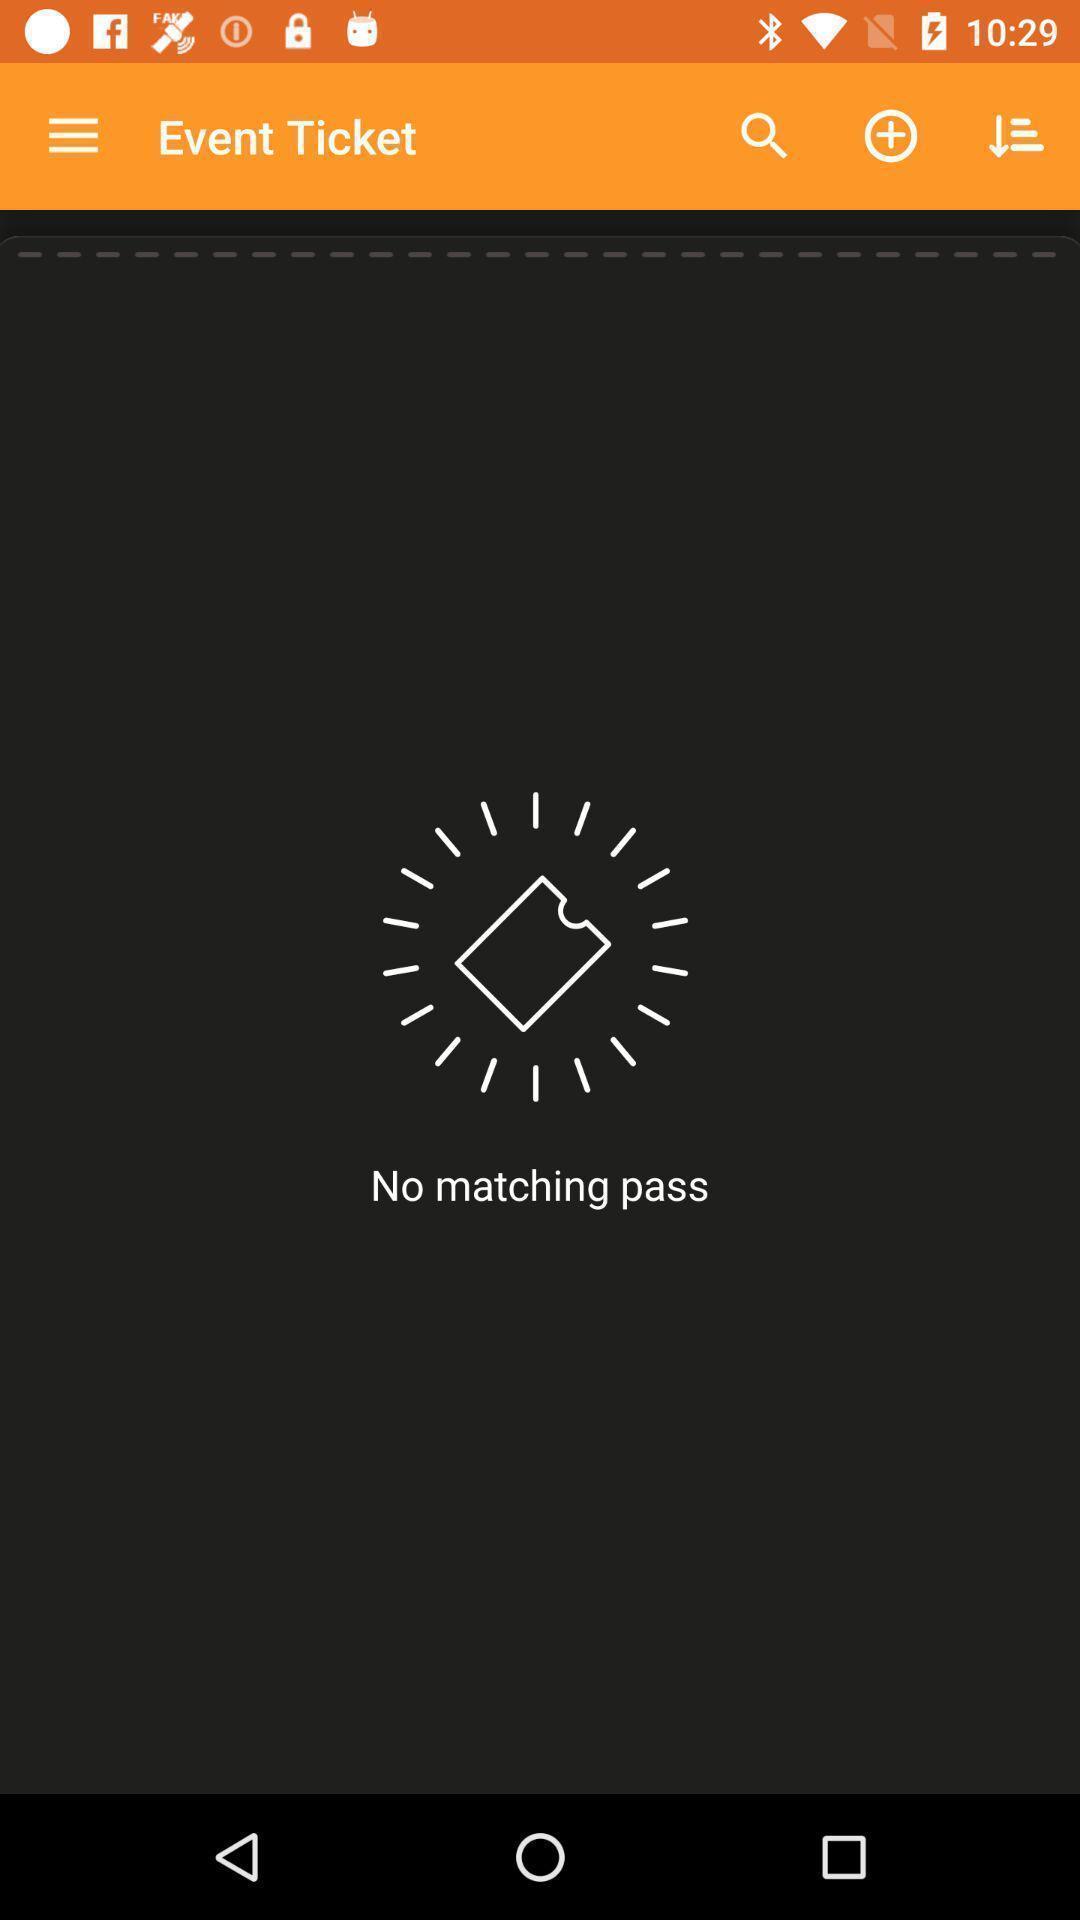Explain what's happening in this screen capture. Page for the service application. 